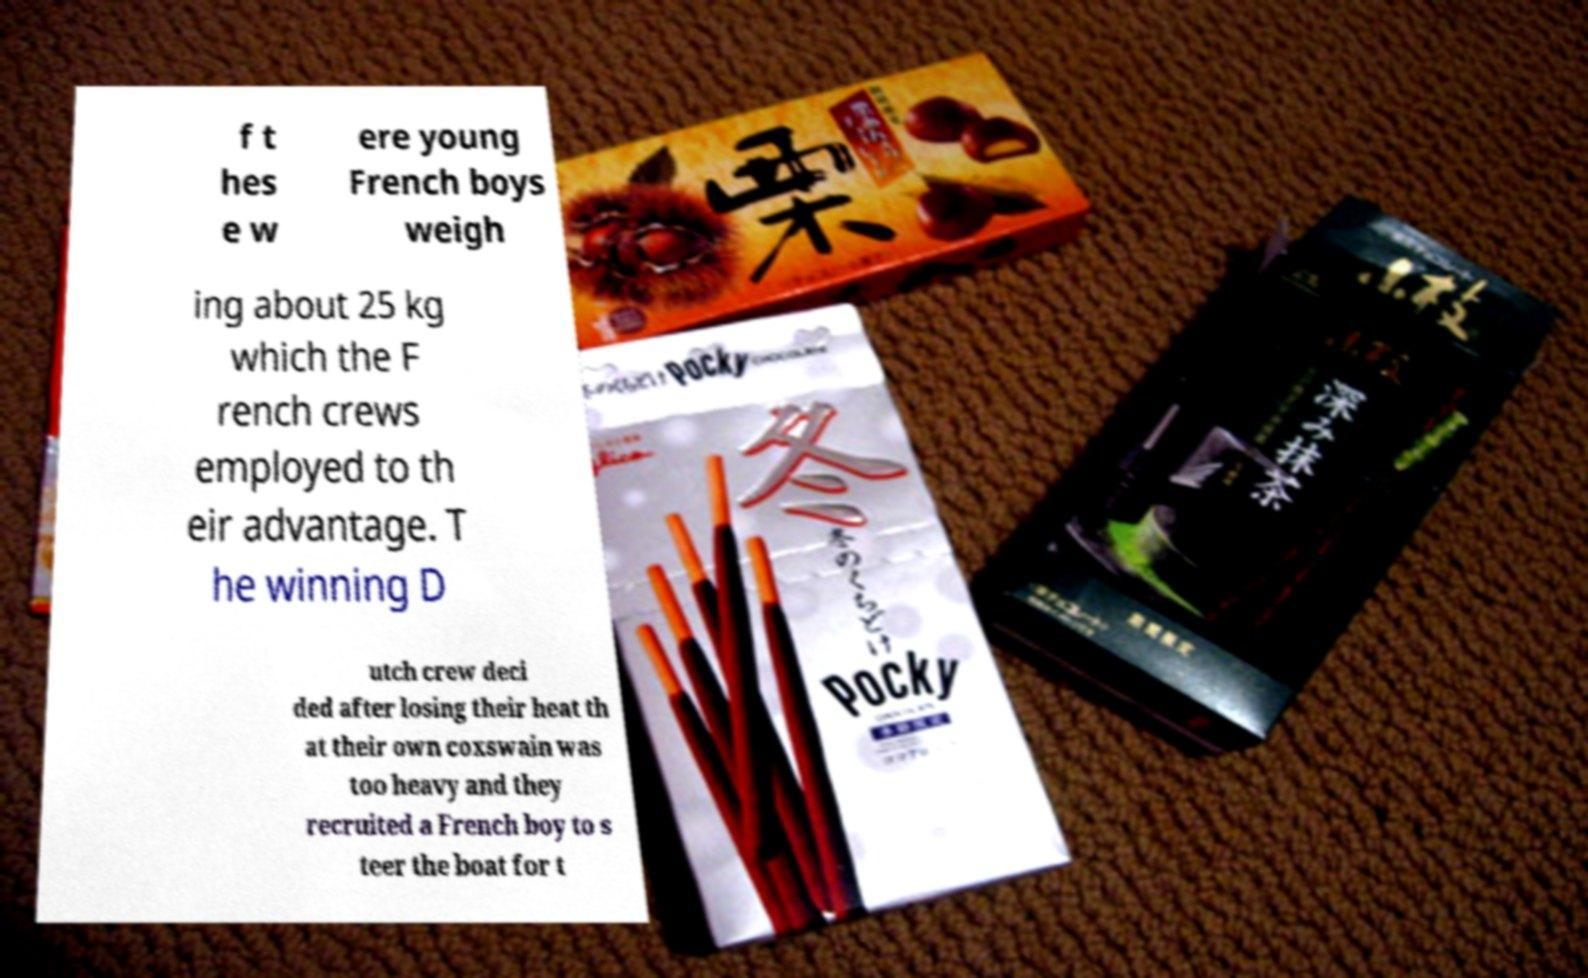Please read and relay the text visible in this image. What does it say? f t hes e w ere young French boys weigh ing about 25 kg which the F rench crews employed to th eir advantage. T he winning D utch crew deci ded after losing their heat th at their own coxswain was too heavy and they recruited a French boy to s teer the boat for t 